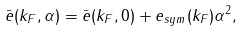Convert formula to latex. <formula><loc_0><loc_0><loc_500><loc_500>\bar { e } ( k _ { F } , \alpha ) = \bar { e } ( k _ { F } , 0 ) + e _ { s y m } ( k _ { F } ) \alpha ^ { 2 } ,</formula> 